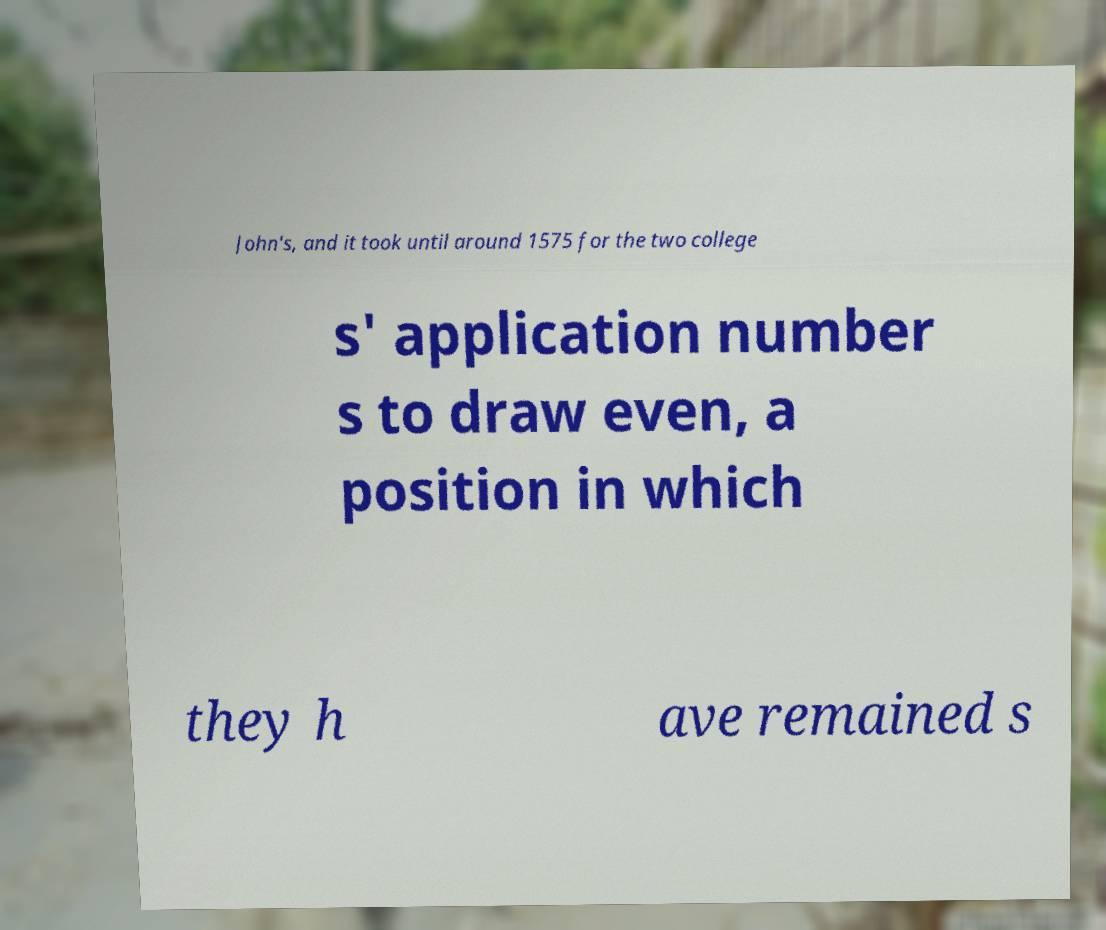Could you extract and type out the text from this image? John's, and it took until around 1575 for the two college s' application number s to draw even, a position in which they h ave remained s 